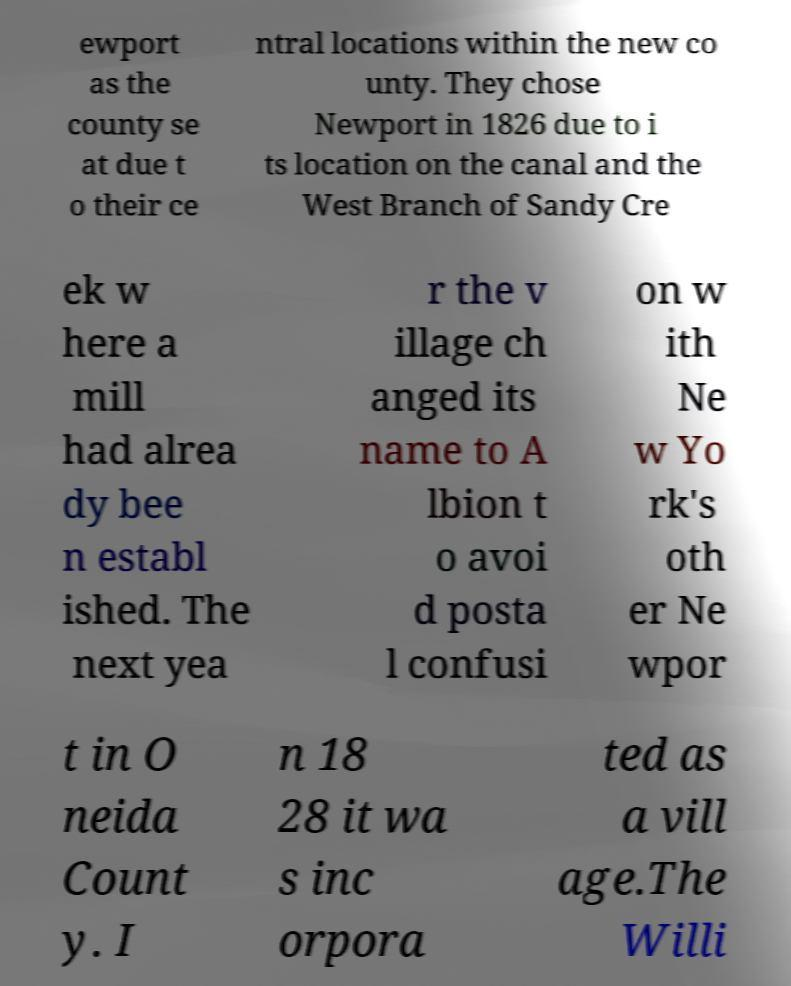Can you accurately transcribe the text from the provided image for me? ewport as the county se at due t o their ce ntral locations within the new co unty. They chose Newport in 1826 due to i ts location on the canal and the West Branch of Sandy Cre ek w here a mill had alrea dy bee n establ ished. The next yea r the v illage ch anged its name to A lbion t o avoi d posta l confusi on w ith Ne w Yo rk's oth er Ne wpor t in O neida Count y. I n 18 28 it wa s inc orpora ted as a vill age.The Willi 